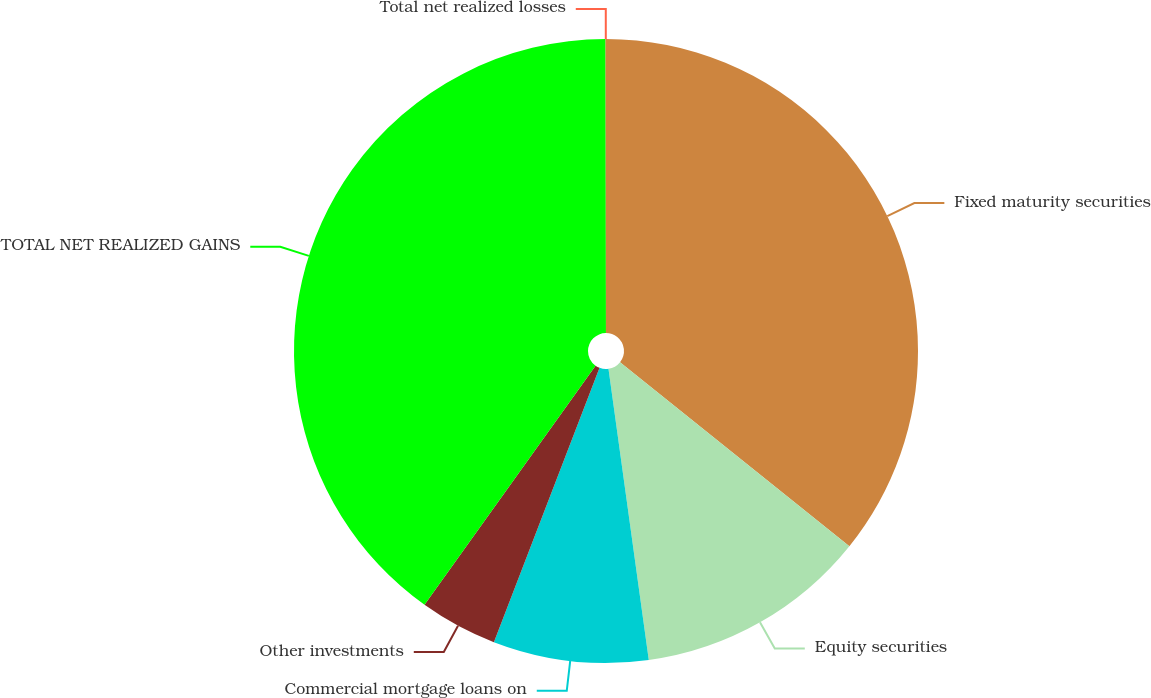Convert chart. <chart><loc_0><loc_0><loc_500><loc_500><pie_chart><fcel>Fixed maturity securities<fcel>Equity securities<fcel>Commercial mortgage loans on<fcel>Other investments<fcel>TOTAL NET REALIZED GAINS<fcel>Total net realized losses<nl><fcel>35.76%<fcel>12.05%<fcel>8.04%<fcel>4.03%<fcel>40.1%<fcel>0.02%<nl></chart> 